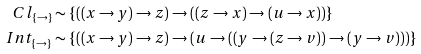Convert formula to latex. <formula><loc_0><loc_0><loc_500><loc_500>C l _ { \{ \to \} } & \sim \{ ( ( x \to y ) \to z ) \to ( ( z \to x ) \to ( u \to x ) ) \} \\ I n t _ { \{ \to \} } & \sim \{ ( ( x \to y ) \to z ) \to ( u \to ( ( y \to ( z \to v ) ) \to ( y \to v ) ) ) \}</formula> 